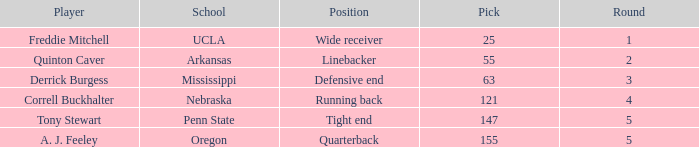What position did a. j. feeley play who was picked in round 5? Quarterback. Would you mind parsing the complete table? {'header': ['Player', 'School', 'Position', 'Pick', 'Round'], 'rows': [['Freddie Mitchell', 'UCLA', 'Wide receiver', '25', '1'], ['Quinton Caver', 'Arkansas', 'Linebacker', '55', '2'], ['Derrick Burgess', 'Mississippi', 'Defensive end', '63', '3'], ['Correll Buckhalter', 'Nebraska', 'Running back', '121', '4'], ['Tony Stewart', 'Penn State', 'Tight end', '147', '5'], ['A. J. Feeley', 'Oregon', 'Quarterback', '155', '5']]} 